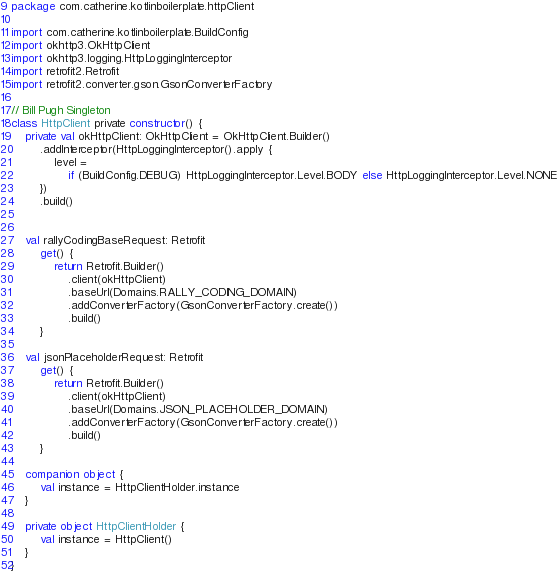<code> <loc_0><loc_0><loc_500><loc_500><_Kotlin_>package com.catherine.kotlinboilerplate.httpClient

import com.catherine.kotlinboilerplate.BuildConfig
import okhttp3.OkHttpClient
import okhttp3.logging.HttpLoggingInterceptor
import retrofit2.Retrofit
import retrofit2.converter.gson.GsonConverterFactory

// Bill Pugh Singleton
class HttpClient private constructor() {
    private val okHttpClient: OkHttpClient = OkHttpClient.Builder()
        .addInterceptor(HttpLoggingInterceptor().apply {
            level =
                if (BuildConfig.DEBUG) HttpLoggingInterceptor.Level.BODY else HttpLoggingInterceptor.Level.NONE
        })
        .build()


    val rallyCodingBaseRequest: Retrofit
        get() {
            return Retrofit.Builder()
                .client(okHttpClient)
                .baseUrl(Domains.RALLY_CODING_DOMAIN)
                .addConverterFactory(GsonConverterFactory.create())
                .build()
        }

    val jsonPlaceholderRequest: Retrofit
        get() {
            return Retrofit.Builder()
                .client(okHttpClient)
                .baseUrl(Domains.JSON_PLACEHOLDER_DOMAIN)
                .addConverterFactory(GsonConverterFactory.create())
                .build()
        }

    companion object {
        val instance = HttpClientHolder.instance
    }

    private object HttpClientHolder {
        val instance = HttpClient()
    }
}</code> 